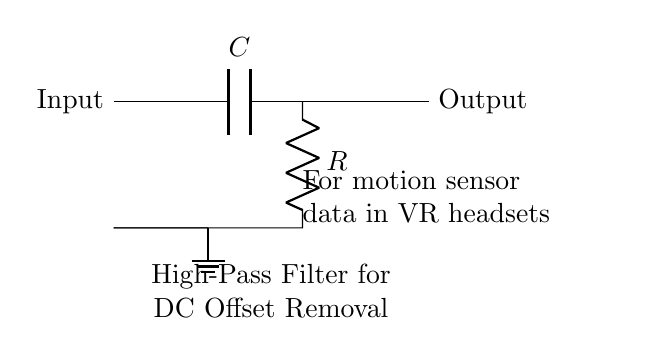What components are in this circuit? The circuit has a capacitor and a resistor, which are essential for forming a high-pass filter. The capacitor is responsible for blocking DC voltage, while the resistor defines the frequency response with the capacitor.
Answer: Capacitor and resistor What is the input to the circuit? The input is indicated at the left side of the circuit diagram, where the motion sensor data is fed into the capacitor. This data typically contains both AC and DC components.
Answer: Input What is the primary function of this circuit? The primary function of this high-pass filter circuit is to remove the DC offset from the incoming sensor data, allowing the AC variations to pass through to the output. This is crucial for accurate data analysis in VR applications.
Answer: Remove DC offset What type of filter is represented in the circuit? The circuit represents a high-pass filter, which allows higher frequencies to pass while attenuating lower frequencies, including DC signals. This is identified by the arrangement of the capacitor and resistor.
Answer: High-pass filter What happens to DC signals in this circuit? DC signals are blocked by the capacitor in the high-pass filter configuration, meaning they do not reach the output. This allows the circuit to effectively isolate the AC signals of interest.
Answer: Blocked What is the purpose of the resistor in the circuit? The resistor defines the time constant of the circuit when paired with the capacitor, influencing the cutoff frequency of the high-pass filter. This determines how quickly the circuit reacts to changes in the input signal.
Answer: Define time constant What characteristic is critical for selecting the capacitor value in this circuit? The capacitance value determines the cutoff frequency of the high-pass filter and impacts the frequency range that can pass through the circuit while blocking DC. Selecting the capacitor value requires knowledge of the target signal frequency range.
Answer: Cutoff frequency 